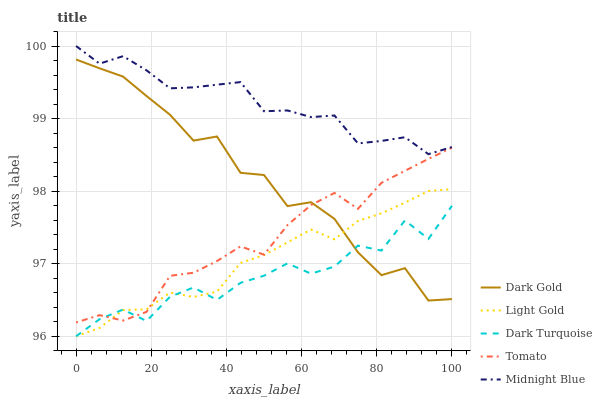Does Light Gold have the minimum area under the curve?
Answer yes or no. No. Does Light Gold have the maximum area under the curve?
Answer yes or no. No. Is Dark Turquoise the smoothest?
Answer yes or no. No. Is Light Gold the roughest?
Answer yes or no. No. Does Midnight Blue have the lowest value?
Answer yes or no. No. Does Light Gold have the highest value?
Answer yes or no. No. Is Dark Gold less than Midnight Blue?
Answer yes or no. Yes. Is Midnight Blue greater than Dark Turquoise?
Answer yes or no. Yes. Does Dark Gold intersect Midnight Blue?
Answer yes or no. No. 